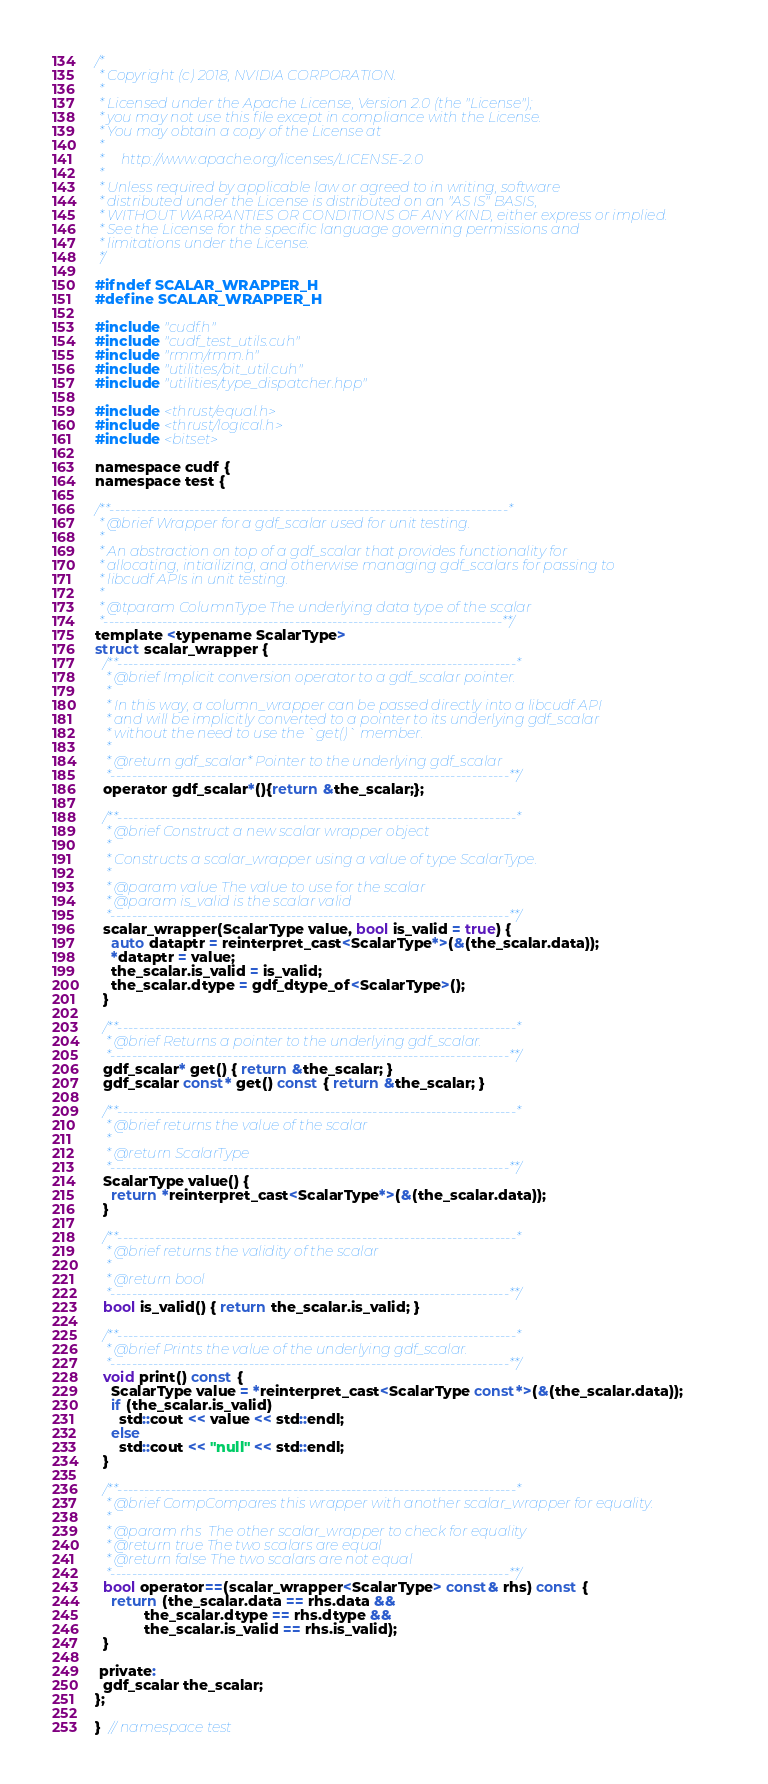Convert code to text. <code><loc_0><loc_0><loc_500><loc_500><_Cuda_>/*
 * Copyright (c) 2018, NVIDIA CORPORATION.
 *
 * Licensed under the Apache License, Version 2.0 (the "License");
 * you may not use this file except in compliance with the License.
 * You may obtain a copy of the License at
 *
 *     http://www.apache.org/licenses/LICENSE-2.0
 *
 * Unless required by applicable law or agreed to in writing, software
 * distributed under the License is distributed on an "AS IS" BASIS,
 * WITHOUT WARRANTIES OR CONDITIONS OF ANY KIND, either express or implied.
 * See the License for the specific language governing permissions and
 * limitations under the License.
 */

#ifndef SCALAR_WRAPPER_H
#define SCALAR_WRAPPER_H

#include "cudf.h"
#include "cudf_test_utils.cuh"
#include "rmm/rmm.h"
#include "utilities/bit_util.cuh"
#include "utilities/type_dispatcher.hpp"

#include <thrust/equal.h>
#include <thrust/logical.h>
#include <bitset>

namespace cudf {
namespace test {

/**---------------------------------------------------------------------------*
 * @brief Wrapper for a gdf_scalar used for unit testing.
 *
 * An abstraction on top of a gdf_scalar that provides functionality for
 * allocating, intiailizing, and otherwise managing gdf_scalars for passing to
 * libcudf APIs in unit testing.
 *
 * @tparam ColumnType The underlying data type of the scalar
 *---------------------------------------------------------------------------**/
template <typename ScalarType>
struct scalar_wrapper {
  /**---------------------------------------------------------------------------*
   * @brief Implicit conversion operator to a gdf_scalar pointer.
   *
   * In this way, a column_wrapper can be passed directly into a libcudf API
   * and will be implicitly converted to a pointer to its underlying gdf_scalar
   * without the need to use the `get()` member.
   *
   * @return gdf_scalar* Pointer to the underlying gdf_scalar
   *---------------------------------------------------------------------------**/
  operator gdf_scalar*(){return &the_scalar;};

  /**---------------------------------------------------------------------------*
   * @brief Construct a new scalar wrapper object
   *
   * Constructs a scalar_wrapper using a value of type ScalarType.
   *
   * @param value The value to use for the scalar
   * @param is_valid is the scalar valid
   *---------------------------------------------------------------------------**/
  scalar_wrapper(ScalarType value, bool is_valid = true) {
    auto dataptr = reinterpret_cast<ScalarType*>(&(the_scalar.data));
    *dataptr = value;
    the_scalar.is_valid = is_valid;
    the_scalar.dtype = gdf_dtype_of<ScalarType>();
  }

  /**---------------------------------------------------------------------------*
   * @brief Returns a pointer to the underlying gdf_scalar.
   *---------------------------------------------------------------------------**/
  gdf_scalar* get() { return &the_scalar; }
  gdf_scalar const* get() const { return &the_scalar; }

  /**---------------------------------------------------------------------------*
   * @brief returns the value of the scalar
   * 
   * @return ScalarType 
   *---------------------------------------------------------------------------**/
  ScalarType value() {
    return *reinterpret_cast<ScalarType*>(&(the_scalar.data));
  }

  /**---------------------------------------------------------------------------*
   * @brief returns the validity of the scalar
   * 
   * @return bool 
   *---------------------------------------------------------------------------**/
  bool is_valid() { return the_scalar.is_valid; }

  /**---------------------------------------------------------------------------*
   * @brief Prints the value of the underlying gdf_scalar.
   *---------------------------------------------------------------------------**/
  void print() const {
    ScalarType value = *reinterpret_cast<ScalarType const*>(&(the_scalar.data));
    if (the_scalar.is_valid)
      std::cout << value << std::endl;
    else
      std::cout << "null" << std::endl;
  }

  /**---------------------------------------------------------------------------*
   * @brief CompCompares this wrapper with another scalar_wrapper for equality.
   *
   * @param rhs  The other scalar_wrapper to check for equality
   * @return true The two scalars are equal
   * @return false The two scalars are not equal
   *---------------------------------------------------------------------------**/
  bool operator==(scalar_wrapper<ScalarType> const& rhs) const {
    return (the_scalar.data == rhs.data &&
            the_scalar.dtype == rhs.dtype &&
            the_scalar.is_valid == rhs.is_valid);
  }

 private:
  gdf_scalar the_scalar;
};

}  // namespace test</code> 